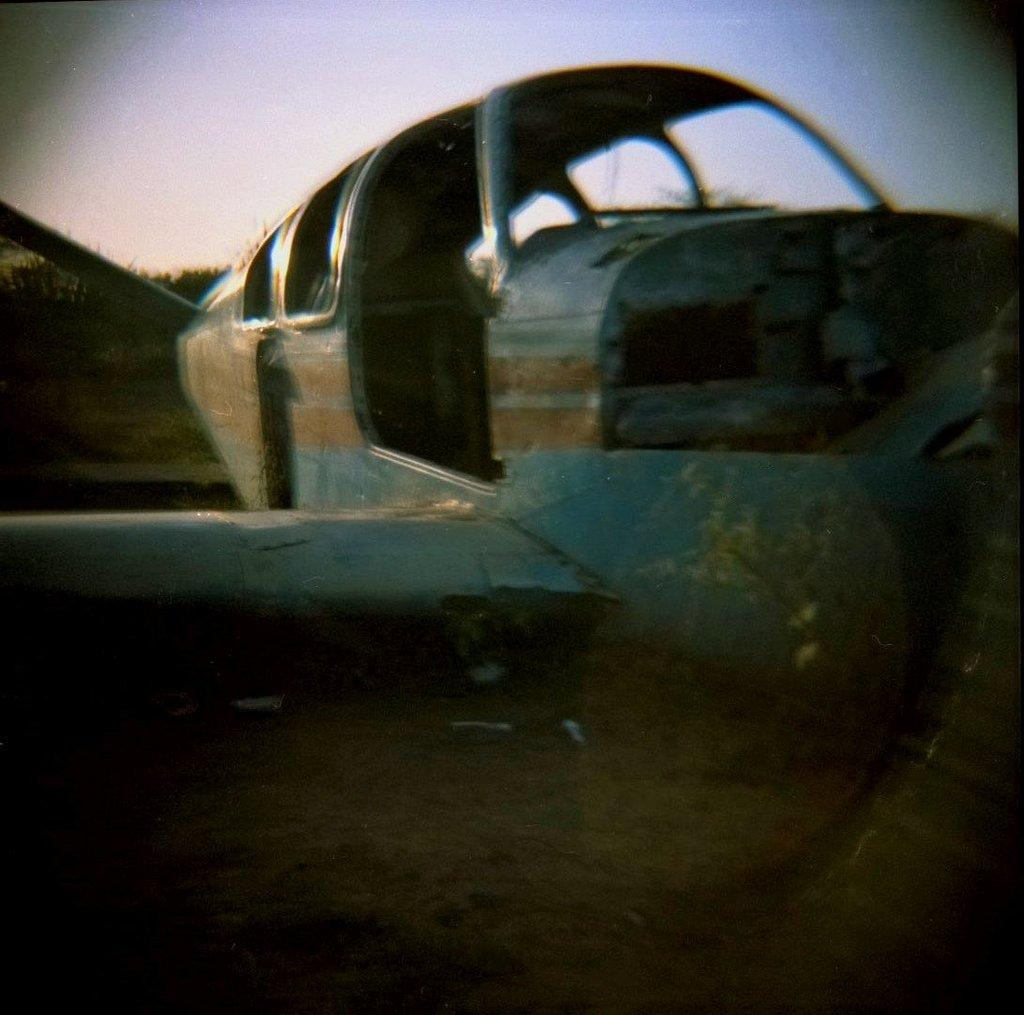What is the main subject of the picture? The main subject of the picture is an airplane frame. What color is the airplane frame? The airplane frame is blue in color. What can be seen in the background of the picture? The sky is clear in the background of the picture. How many volleyballs are visible on the airplane frame in the image? There are no volleyballs present in the image; it features an airplane frame. What type of needle is being used to sew the airplane frame in the image? There is no needle present in the image, as it features an airplane frame and a clear sky. 